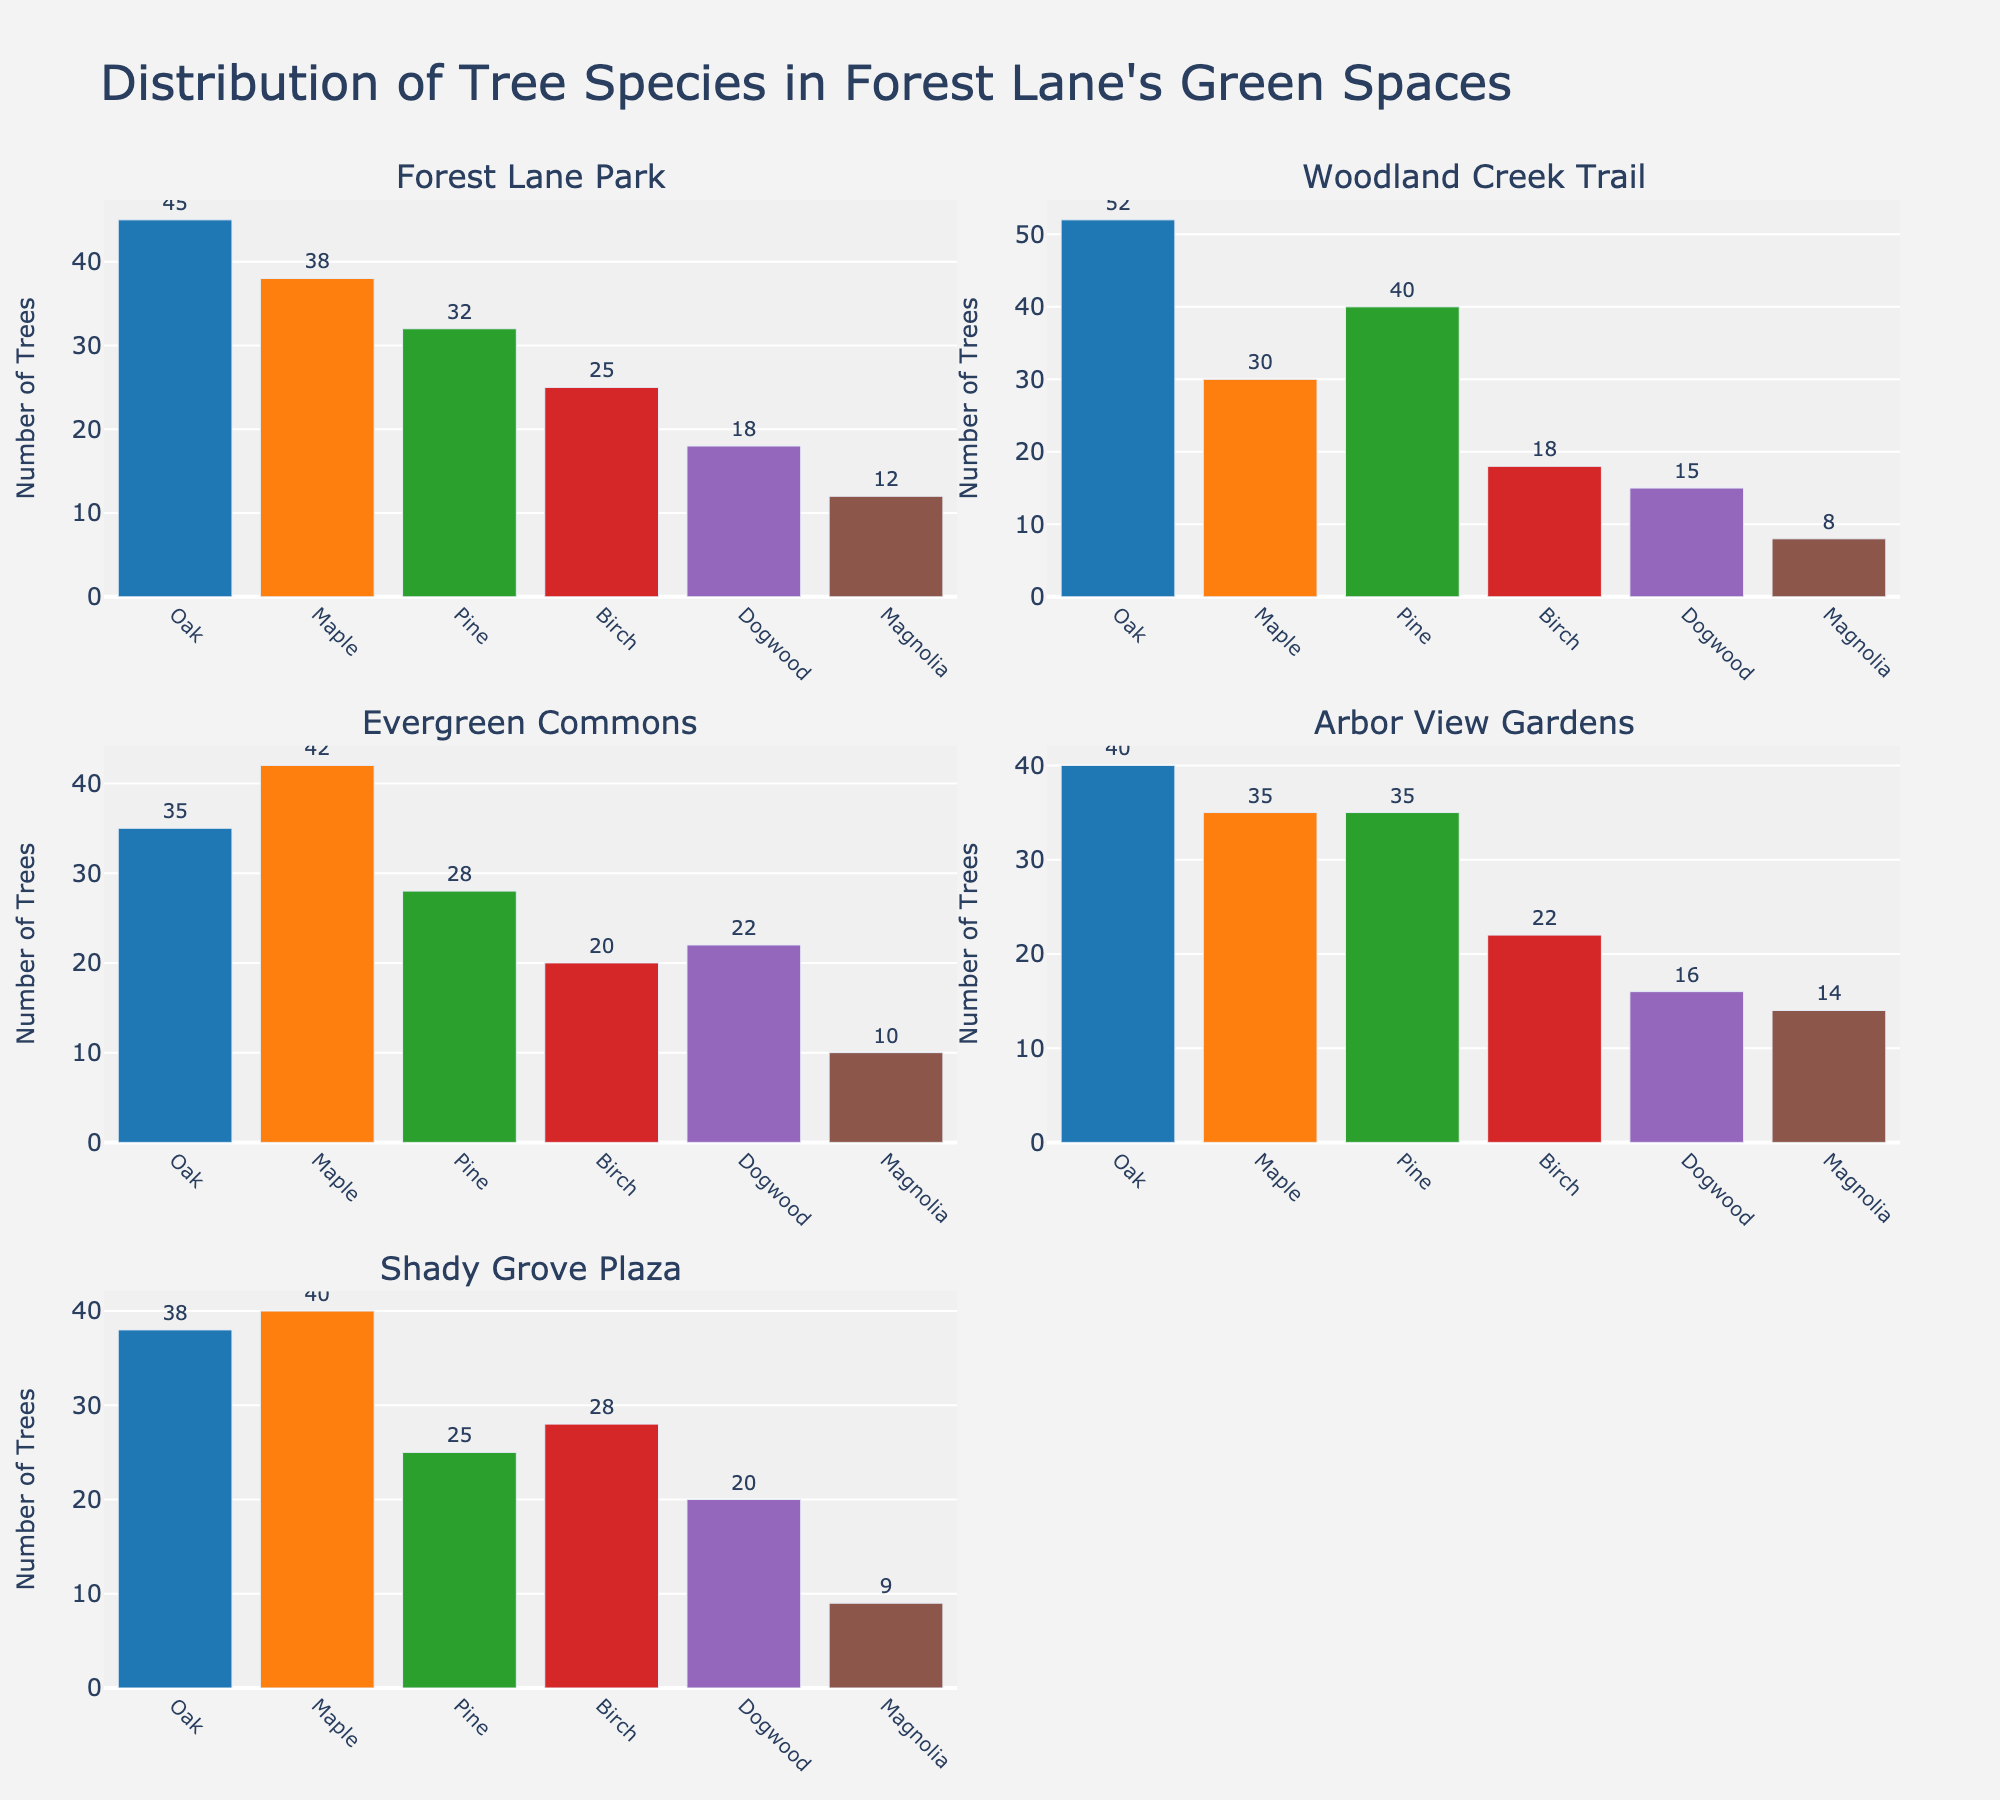What is the title of the figure? The title of the figure is located at the top and usually provides a summary of what the figure represents. In this case, it should state what the figure is about.
Answer: Distribution of Tree Species in Forest Lane's Green Spaces Which tree species is most prevalent in Forest Lane Park? To determine the most prevalent tree species, look at the bar with the highest value in the subplot for Forest Lane Park.
Answer: Oak How many more Oak trees than Birch trees are there in Woodland Creek Trail? Check the subplot for Woodland Creek Trail. Find the values for Oak and Birch trees and calculate the difference. There are 52 Oak trees and 18 Birch trees, so 52 - 18 = 34.
Answer: 34 Compare the number of Dogwood trees in Evergreen Commons to Shady Grove Plaza. Which green space has fewer Dogwood trees? Look at the subplots for Evergreen Commons and Shady Grove Plaza. Check the values for Dogwood trees in both subplots and compare. Evergreen Commons has 22 Dogwood trees, and Shady Grove Plaza has 20.
Answer: Shady Grove Plaza What is the average number of Pine trees across all green spaces? Add up the number of Pine trees in each subplot and divide by the number of green spaces. (32 + 40 + 28 + 35 + 25) = 160, and there are 5 green spaces, so the average is 160/5 = 32.
Answer: 32 Which green space has the second highest number of Maple trees? Identify the number of Maple trees in each subplot and determine which value is the second highest. The highest is in Evergreen Commons (42), and the second highest is in Shady Grove Plaza (40).
Answer: Shady Grove Plaza Is Magnolia the least common tree species in any of the green spaces? For each subplot, identify the tree species with the lowest value and check if Magnolia is among them. In Woodland Creek Trail, Magnolia is the least common with 8 trees.
Answer: Yes In which green space is the distribution of tree species most balanced? Assess the height of bars in each subplot to see which one has the most similar heights across different tree species. Arbor View Gardens has relatively balanced numbers across all tree species.
Answer: Arbor View Gardens How many total trees are there in Shady Grove Plaza? Sum up the values for all tree species in the Shady Grove Plaza subplot. 38 (Oak) + 40 (Maple) + 25 (Pine) + 28 (Birch) + 20 (Dogwood) + 9 (Magnolia) = 160.
Answer: 160 